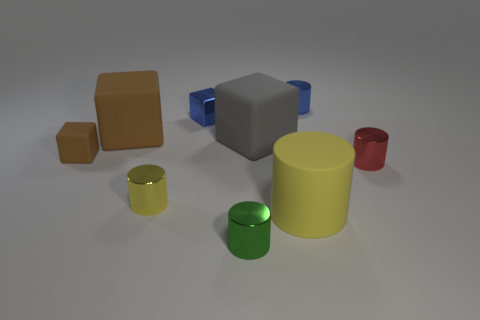There is a small rubber object; what shape is it?
Offer a terse response. Cube. The cylinder that is behind the small cylinder on the right side of the tiny blue metallic cylinder is what color?
Offer a terse response. Blue. There is a blue thing that is left of the blue metal cylinder; how big is it?
Your answer should be very brief. Small. Is there a big blue cube that has the same material as the gray object?
Your answer should be compact. No. What number of tiny yellow metal objects have the same shape as the gray rubber object?
Give a very brief answer. 0. The small blue shiny object that is to the right of the small thing in front of the yellow cylinder that is behind the big matte cylinder is what shape?
Your response must be concise. Cylinder. What material is the small object that is both right of the small green thing and behind the red object?
Give a very brief answer. Metal. Does the yellow cylinder behind the yellow matte cylinder have the same size as the tiny green thing?
Offer a terse response. Yes. Is there anything else that is the same size as the gray matte block?
Provide a short and direct response. Yes. Are there more small blue cylinders to the right of the gray rubber block than yellow objects to the right of the metal block?
Offer a terse response. No. 